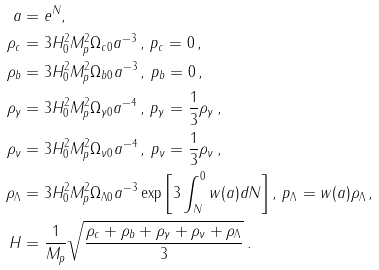<formula> <loc_0><loc_0><loc_500><loc_500>a & = e ^ { N } , \\ \rho _ { c } & = 3 H _ { 0 } ^ { 2 } M _ { p } ^ { 2 } \Omega _ { c 0 } a ^ { - 3 } \, , \, p _ { c } = 0 \, , \\ \rho _ { b } & = 3 H _ { 0 } ^ { 2 } M _ { p } ^ { 2 } \Omega _ { b 0 } a ^ { - 3 } \, , \, p _ { b } = 0 \, , \\ \rho _ { \gamma } & = 3 H _ { 0 } ^ { 2 } M _ { p } ^ { 2 } \Omega _ { \gamma 0 } a ^ { - 4 } \, , \, p _ { \gamma } = \frac { 1 } { 3 } \rho _ { \gamma } \, , \\ \rho _ { \nu } & = 3 H _ { 0 } ^ { 2 } M _ { p } ^ { 2 } \Omega _ { \nu 0 } a ^ { - 4 } \, , \, p _ { \nu } = \frac { 1 } { 3 } \rho _ { \nu } \, , \\ \rho _ { \Lambda } & = 3 H _ { 0 } ^ { 2 } M _ { p } ^ { 2 } \Omega _ { \Lambda 0 } a ^ { - 3 } \exp { \left [ 3 \int _ { N } ^ { 0 } w ( a ) d N \right ] } \, , \, p _ { \Lambda } = w ( a ) \rho _ { \Lambda } \, , \\ H & = \frac { 1 } { M _ { p } } \sqrt { \frac { \rho _ { c } + \rho _ { b } + \rho _ { \gamma } + \rho _ { \nu } + \rho _ { \Lambda } } { 3 } } \, .</formula> 